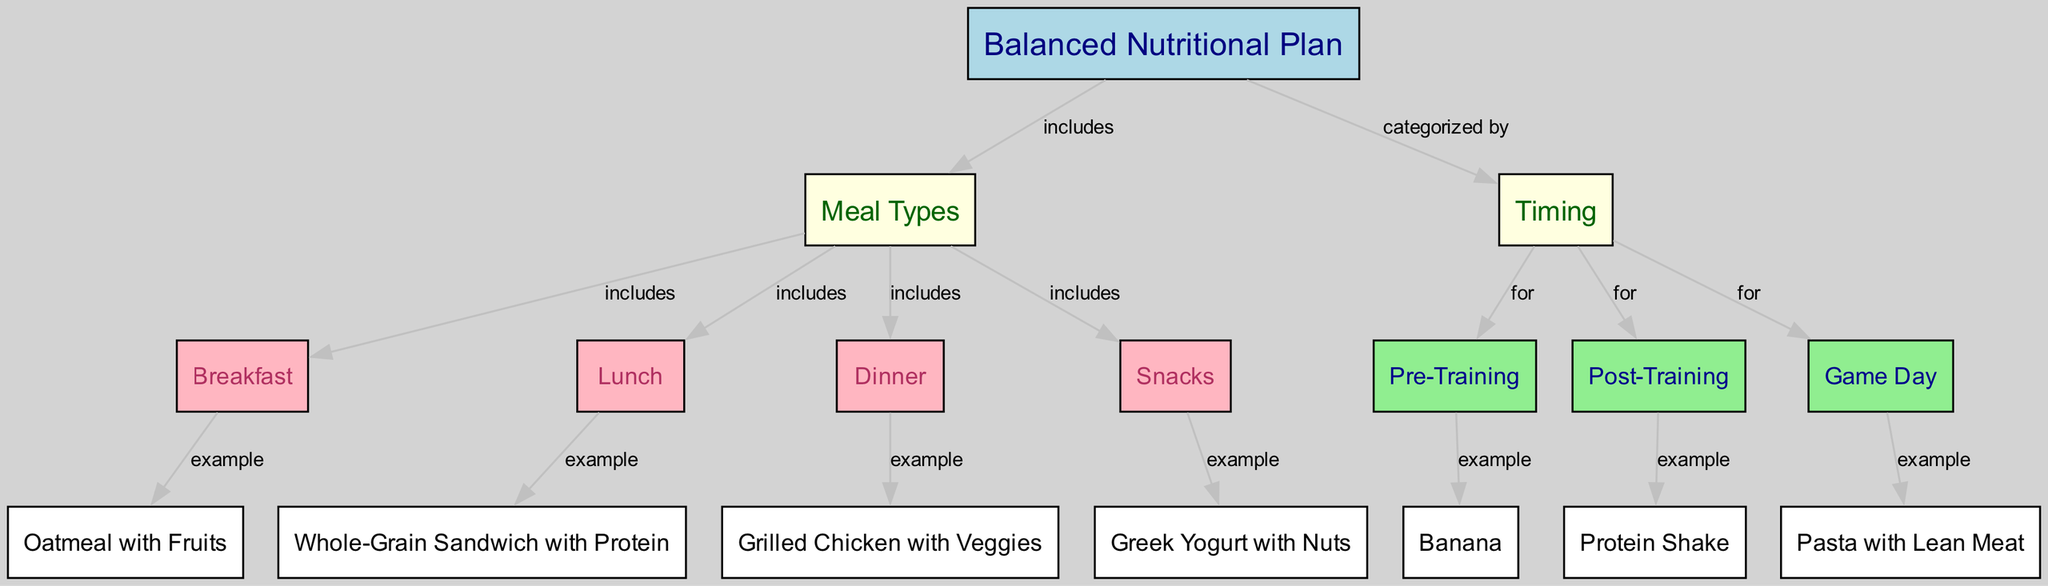What are the main meal types in a balanced nutritional plan? The diagram lists four main meal types: Breakfast, Lunch, Dinner, and Snacks. These types are directly connected to the "Meal Types" node, indicating they are included in the balanced nutritional plan.
Answer: Breakfast, Lunch, Dinner, Snacks How many meal types are included in the plan? The "Meal Types" node connects to four meals: Breakfast, Lunch, Dinner, and Snacks, which makes a total of four meal types in the diagram.
Answer: Four What is an example meal for Breakfast? The diagram indicates that "Oatmeal with Fruits" is an example meal connected to the Breakfast node. Hence, this meal qualifies as a breakfast example.
Answer: Oatmeal with Fruits Which meal is suggested for Post-Training? The meal listed under the Post-Training node is "Protein Shake," which serves as an example meal to consume after training sessions.
Answer: Protein Shake What does the 'Game Day' category include? The diagram shows that 'Game Day' includes the meal type 'Pasta with Lean Meat' as an example, indicating this is recommended for game days.
Answer: Pasta with Lean Meat How are meals categorized in this nutritional plan? The nutritional plan categorizes meals based on their timing, specifically for Pre-Training, Post-Training, and Game Day. This structure connects the "Meal Types" node to the "Timing" node.
Answer: By Timing What example meal is recommended for Snacks? The diagram presents "Greek Yogurt with Nuts" as the example meal for the Snacks category, indicating a nutritious option to consider.
Answer: Greek Yogurt with Nuts Which meals should be consumed before training? The Pre-Training node shows "Banana" as an example meal, which is specifically recommended to consume before engaging in training sessions.
Answer: Banana What type of meals are designed for practice and games? The meals designed for practice and games are categorized under Pre-Training, Post-Training, and Game Day sections and their corresponding example meals represent energy-boosting options for these times.
Answer: Energy-boosting meals 